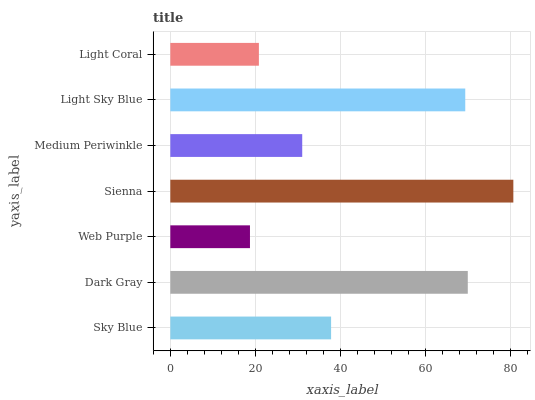Is Web Purple the minimum?
Answer yes or no. Yes. Is Sienna the maximum?
Answer yes or no. Yes. Is Dark Gray the minimum?
Answer yes or no. No. Is Dark Gray the maximum?
Answer yes or no. No. Is Dark Gray greater than Sky Blue?
Answer yes or no. Yes. Is Sky Blue less than Dark Gray?
Answer yes or no. Yes. Is Sky Blue greater than Dark Gray?
Answer yes or no. No. Is Dark Gray less than Sky Blue?
Answer yes or no. No. Is Sky Blue the high median?
Answer yes or no. Yes. Is Sky Blue the low median?
Answer yes or no. Yes. Is Dark Gray the high median?
Answer yes or no. No. Is Light Sky Blue the low median?
Answer yes or no. No. 